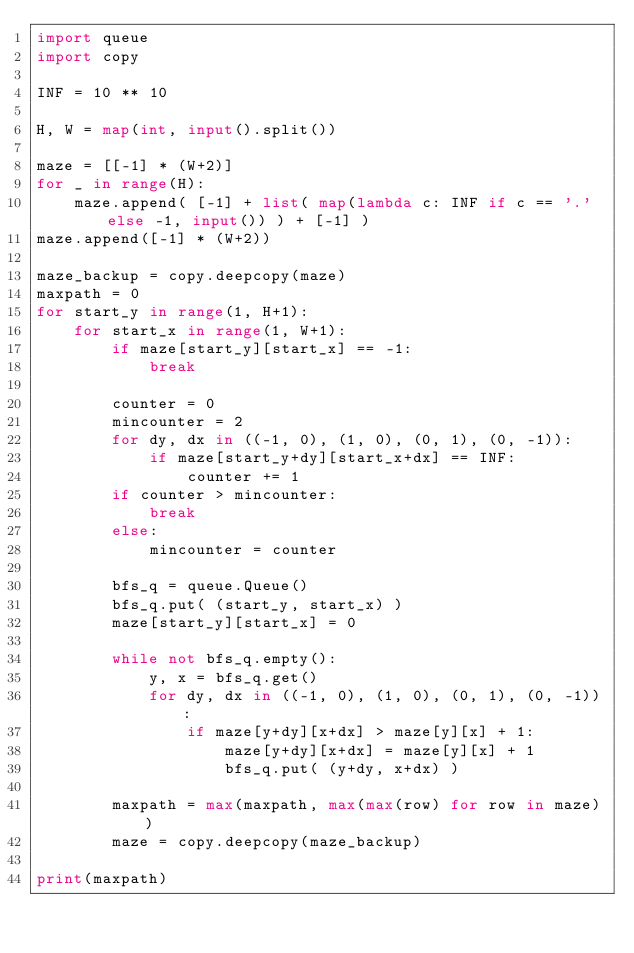Convert code to text. <code><loc_0><loc_0><loc_500><loc_500><_Python_>import queue
import copy

INF = 10 ** 10

H, W = map(int, input().split())

maze = [[-1] * (W+2)]
for _ in range(H):
    maze.append( [-1] + list( map(lambda c: INF if c == '.' else -1, input()) ) + [-1] )
maze.append([-1] * (W+2))

maze_backup = copy.deepcopy(maze)
maxpath = 0
for start_y in range(1, H+1):
    for start_x in range(1, W+1):
        if maze[start_y][start_x] == -1:
            break
        
        counter = 0
        mincounter = 2
        for dy, dx in ((-1, 0), (1, 0), (0, 1), (0, -1)):
            if maze[start_y+dy][start_x+dx] == INF:
                counter += 1
        if counter > mincounter:
            break
        else:
            mincounter = counter

        bfs_q = queue.Queue()
        bfs_q.put( (start_y, start_x) )
        maze[start_y][start_x] = 0

        while not bfs_q.empty():
            y, x = bfs_q.get()
            for dy, dx in ((-1, 0), (1, 0), (0, 1), (0, -1)):
                if maze[y+dy][x+dx] > maze[y][x] + 1:
                    maze[y+dy][x+dx] = maze[y][x] + 1
                    bfs_q.put( (y+dy, x+dx) )

        maxpath = max(maxpath, max(max(row) for row in maze))
        maze = copy.deepcopy(maze_backup)

print(maxpath)</code> 